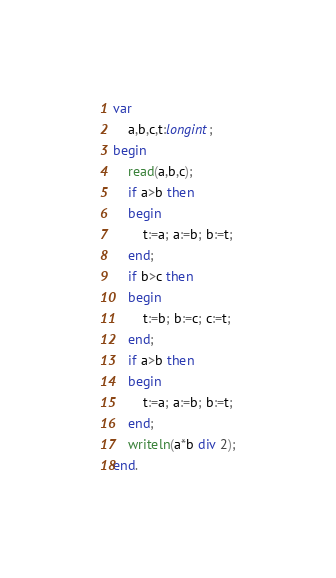<code> <loc_0><loc_0><loc_500><loc_500><_Pascal_>var
	a,b,c,t:longint;
begin
	read(a,b,c);
    if a>b then
    begin
    	t:=a; a:=b; b:=t;
    end;
    if b>c then
    begin
    	t:=b; b:=c; c:=t;
    end;
    if a>b then
    begin
    	t:=a; a:=b; b:=t;
    end;
    writeln(a*b div 2);
end.</code> 